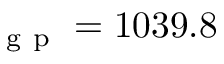<formula> <loc_0><loc_0><loc_500><loc_500>_ { g } p = 1 0 3 9 . 8</formula> 